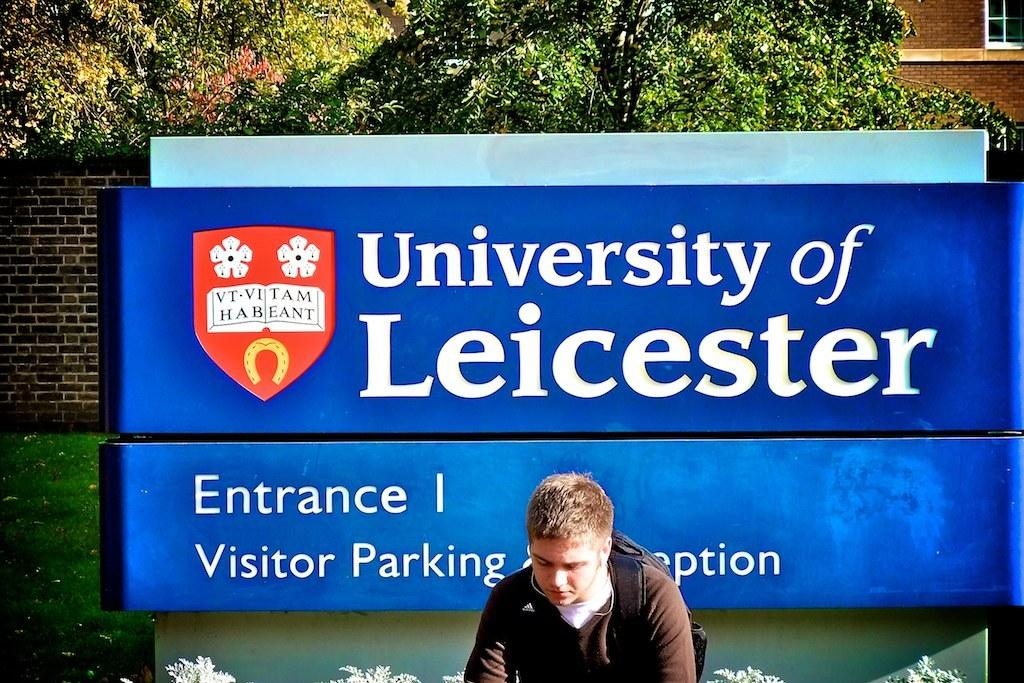Provide a one-sentence caption for the provided image. An entrance I sign for the University of Leicester. 